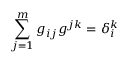<formula> <loc_0><loc_0><loc_500><loc_500>\sum _ { j = 1 } ^ { m } g _ { i j } g ^ { j k } = \delta _ { i } ^ { k }</formula> 